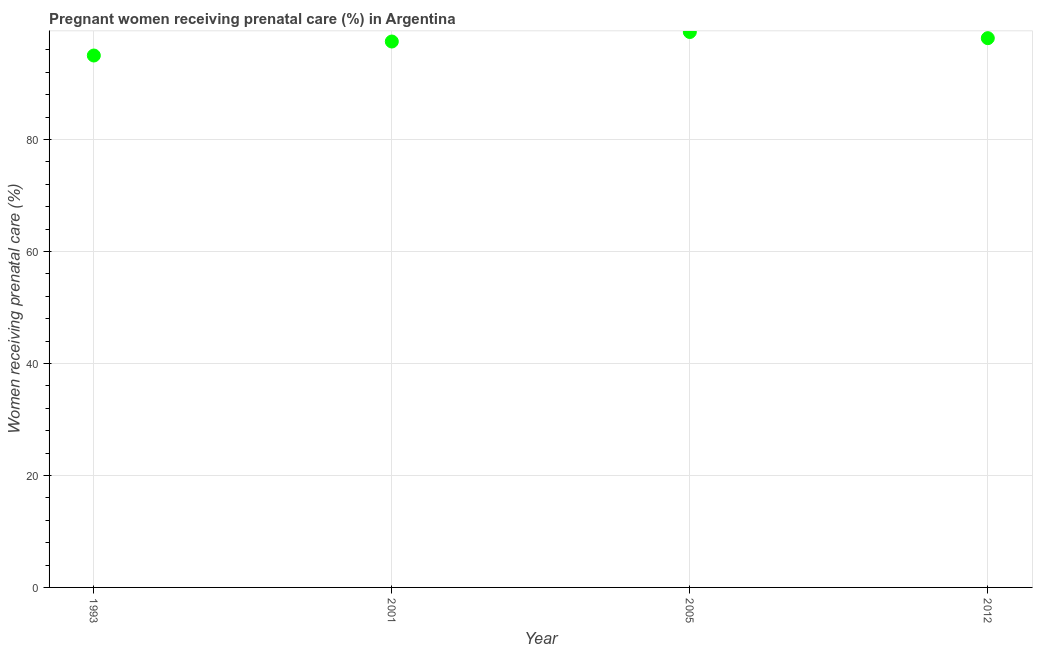What is the percentage of pregnant women receiving prenatal care in 2001?
Ensure brevity in your answer.  97.5. Across all years, what is the maximum percentage of pregnant women receiving prenatal care?
Offer a very short reply. 99.2. Across all years, what is the minimum percentage of pregnant women receiving prenatal care?
Your response must be concise. 95. In which year was the percentage of pregnant women receiving prenatal care maximum?
Make the answer very short. 2005. In which year was the percentage of pregnant women receiving prenatal care minimum?
Offer a terse response. 1993. What is the sum of the percentage of pregnant women receiving prenatal care?
Your answer should be very brief. 389.8. What is the difference between the percentage of pregnant women receiving prenatal care in 1993 and 2012?
Keep it short and to the point. -3.1. What is the average percentage of pregnant women receiving prenatal care per year?
Provide a succinct answer. 97.45. What is the median percentage of pregnant women receiving prenatal care?
Offer a terse response. 97.8. What is the ratio of the percentage of pregnant women receiving prenatal care in 2001 to that in 2012?
Offer a terse response. 0.99. Is the percentage of pregnant women receiving prenatal care in 2005 less than that in 2012?
Offer a very short reply. No. Is the difference between the percentage of pregnant women receiving prenatal care in 2001 and 2005 greater than the difference between any two years?
Ensure brevity in your answer.  No. What is the difference between the highest and the second highest percentage of pregnant women receiving prenatal care?
Make the answer very short. 1.1. What is the difference between the highest and the lowest percentage of pregnant women receiving prenatal care?
Give a very brief answer. 4.2. In how many years, is the percentage of pregnant women receiving prenatal care greater than the average percentage of pregnant women receiving prenatal care taken over all years?
Your answer should be compact. 3. Does the percentage of pregnant women receiving prenatal care monotonically increase over the years?
Provide a short and direct response. No. How many dotlines are there?
Ensure brevity in your answer.  1. Does the graph contain any zero values?
Make the answer very short. No. What is the title of the graph?
Provide a short and direct response. Pregnant women receiving prenatal care (%) in Argentina. What is the label or title of the Y-axis?
Offer a terse response. Women receiving prenatal care (%). What is the Women receiving prenatal care (%) in 1993?
Ensure brevity in your answer.  95. What is the Women receiving prenatal care (%) in 2001?
Offer a terse response. 97.5. What is the Women receiving prenatal care (%) in 2005?
Ensure brevity in your answer.  99.2. What is the Women receiving prenatal care (%) in 2012?
Provide a short and direct response. 98.1. What is the difference between the Women receiving prenatal care (%) in 2001 and 2005?
Your response must be concise. -1.7. What is the difference between the Women receiving prenatal care (%) in 2005 and 2012?
Keep it short and to the point. 1.1. What is the ratio of the Women receiving prenatal care (%) in 1993 to that in 2005?
Your answer should be very brief. 0.96. What is the ratio of the Women receiving prenatal care (%) in 2001 to that in 2005?
Offer a very short reply. 0.98. What is the ratio of the Women receiving prenatal care (%) in 2005 to that in 2012?
Your response must be concise. 1.01. 